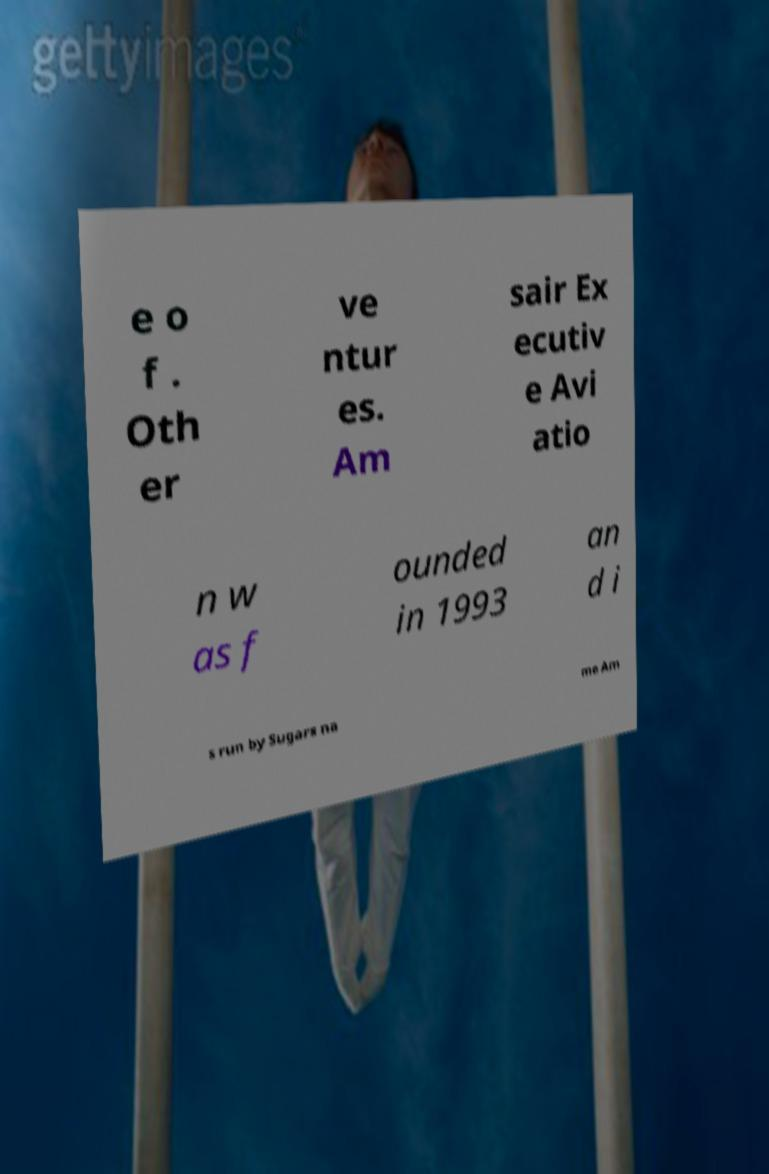What messages or text are displayed in this image? I need them in a readable, typed format. e o f . Oth er ve ntur es. Am sair Ex ecutiv e Avi atio n w as f ounded in 1993 an d i s run by Sugars na me Am 